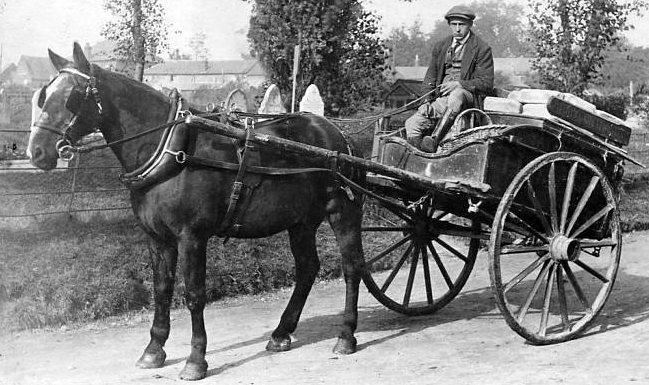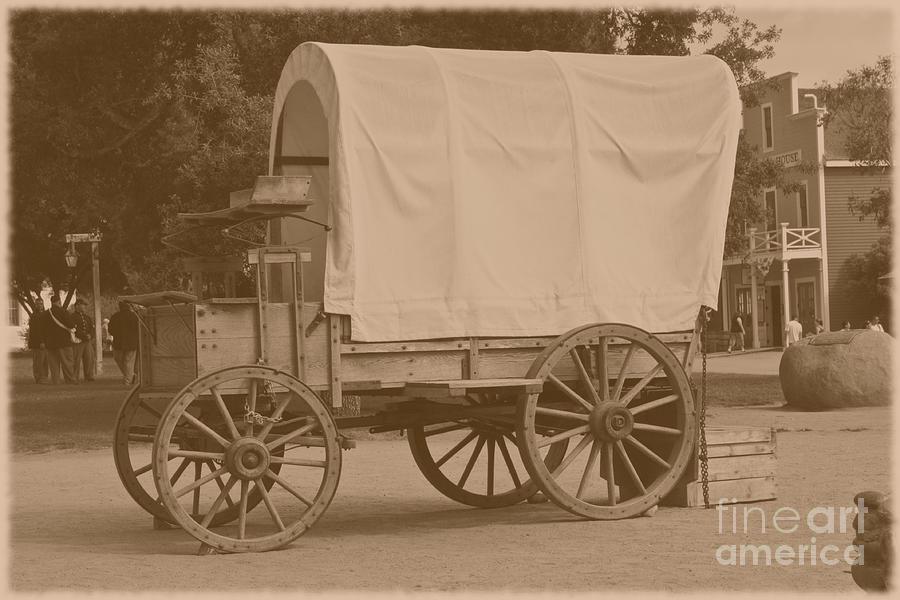The first image is the image on the left, the second image is the image on the right. Examine the images to the left and right. Is the description "An image shows a left-facing horse-drawn cart with only two wheels." accurate? Answer yes or no. Yes. The first image is the image on the left, the second image is the image on the right. For the images shown, is this caption "One image is of a horse-drawn cart with two wheels, while the other image is a larger horse-drawn wagon with four wheels." true? Answer yes or no. Yes. 